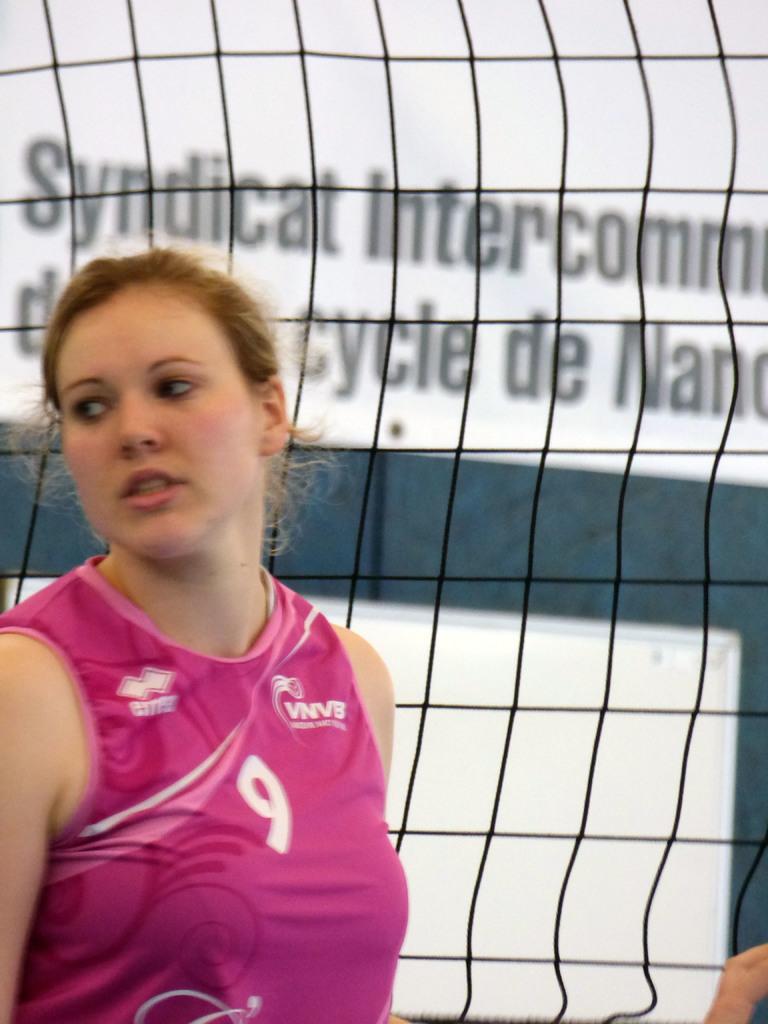What number does she wear?
Your answer should be very brief. 9. What is written on the wall behind her?
Offer a terse response. Syndicat intercomm. 